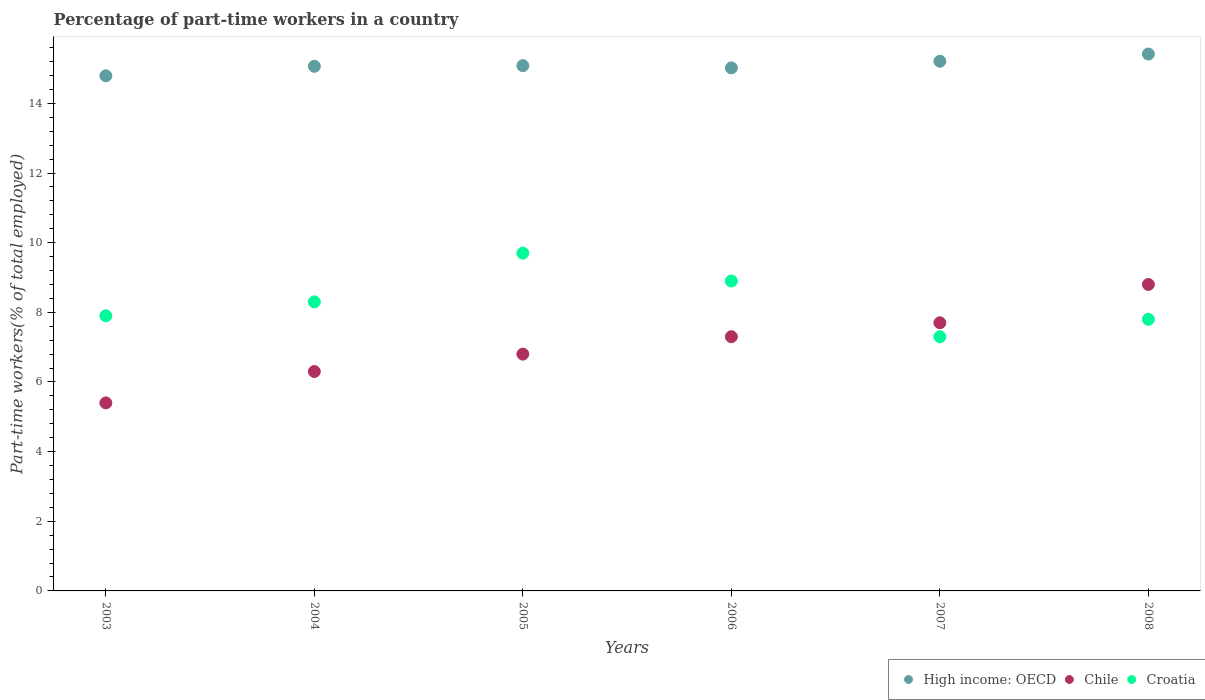How many different coloured dotlines are there?
Offer a very short reply. 3. Is the number of dotlines equal to the number of legend labels?
Offer a very short reply. Yes. What is the percentage of part-time workers in High income: OECD in 2003?
Offer a very short reply. 14.79. Across all years, what is the maximum percentage of part-time workers in High income: OECD?
Provide a succinct answer. 15.42. Across all years, what is the minimum percentage of part-time workers in Croatia?
Give a very brief answer. 7.3. In which year was the percentage of part-time workers in Chile maximum?
Offer a very short reply. 2008. In which year was the percentage of part-time workers in Croatia minimum?
Offer a terse response. 2007. What is the total percentage of part-time workers in Chile in the graph?
Offer a very short reply. 42.3. What is the difference between the percentage of part-time workers in Chile in 2005 and that in 2006?
Offer a terse response. -0.5. What is the difference between the percentage of part-time workers in Croatia in 2004 and the percentage of part-time workers in High income: OECD in 2007?
Keep it short and to the point. -6.91. What is the average percentage of part-time workers in Croatia per year?
Your answer should be very brief. 8.32. In the year 2005, what is the difference between the percentage of part-time workers in High income: OECD and percentage of part-time workers in Chile?
Ensure brevity in your answer.  8.28. What is the ratio of the percentage of part-time workers in Chile in 2003 to that in 2006?
Your answer should be compact. 0.74. What is the difference between the highest and the second highest percentage of part-time workers in High income: OECD?
Provide a short and direct response. 0.21. What is the difference between the highest and the lowest percentage of part-time workers in Croatia?
Provide a short and direct response. 2.4. Is it the case that in every year, the sum of the percentage of part-time workers in High income: OECD and percentage of part-time workers in Croatia  is greater than the percentage of part-time workers in Chile?
Make the answer very short. Yes. Does the percentage of part-time workers in Chile monotonically increase over the years?
Offer a very short reply. Yes. Is the percentage of part-time workers in Croatia strictly less than the percentage of part-time workers in Chile over the years?
Your answer should be very brief. No. How many years are there in the graph?
Offer a terse response. 6. What is the difference between two consecutive major ticks on the Y-axis?
Give a very brief answer. 2. Are the values on the major ticks of Y-axis written in scientific E-notation?
Offer a very short reply. No. Where does the legend appear in the graph?
Ensure brevity in your answer.  Bottom right. What is the title of the graph?
Your answer should be compact. Percentage of part-time workers in a country. Does "Albania" appear as one of the legend labels in the graph?
Your answer should be compact. No. What is the label or title of the X-axis?
Your answer should be very brief. Years. What is the label or title of the Y-axis?
Your response must be concise. Part-time workers(% of total employed). What is the Part-time workers(% of total employed) in High income: OECD in 2003?
Provide a succinct answer. 14.79. What is the Part-time workers(% of total employed) in Chile in 2003?
Your response must be concise. 5.4. What is the Part-time workers(% of total employed) in Croatia in 2003?
Offer a very short reply. 7.9. What is the Part-time workers(% of total employed) of High income: OECD in 2004?
Ensure brevity in your answer.  15.06. What is the Part-time workers(% of total employed) of Chile in 2004?
Provide a short and direct response. 6.3. What is the Part-time workers(% of total employed) in Croatia in 2004?
Offer a terse response. 8.3. What is the Part-time workers(% of total employed) in High income: OECD in 2005?
Keep it short and to the point. 15.08. What is the Part-time workers(% of total employed) in Chile in 2005?
Ensure brevity in your answer.  6.8. What is the Part-time workers(% of total employed) of Croatia in 2005?
Offer a very short reply. 9.7. What is the Part-time workers(% of total employed) in High income: OECD in 2006?
Give a very brief answer. 15.02. What is the Part-time workers(% of total employed) in Chile in 2006?
Your response must be concise. 7.3. What is the Part-time workers(% of total employed) of Croatia in 2006?
Your answer should be very brief. 8.9. What is the Part-time workers(% of total employed) in High income: OECD in 2007?
Make the answer very short. 15.21. What is the Part-time workers(% of total employed) of Chile in 2007?
Keep it short and to the point. 7.7. What is the Part-time workers(% of total employed) of Croatia in 2007?
Ensure brevity in your answer.  7.3. What is the Part-time workers(% of total employed) in High income: OECD in 2008?
Your answer should be compact. 15.42. What is the Part-time workers(% of total employed) of Chile in 2008?
Keep it short and to the point. 8.8. What is the Part-time workers(% of total employed) of Croatia in 2008?
Keep it short and to the point. 7.8. Across all years, what is the maximum Part-time workers(% of total employed) of High income: OECD?
Your answer should be very brief. 15.42. Across all years, what is the maximum Part-time workers(% of total employed) in Chile?
Offer a terse response. 8.8. Across all years, what is the maximum Part-time workers(% of total employed) of Croatia?
Provide a short and direct response. 9.7. Across all years, what is the minimum Part-time workers(% of total employed) of High income: OECD?
Ensure brevity in your answer.  14.79. Across all years, what is the minimum Part-time workers(% of total employed) of Chile?
Offer a terse response. 5.4. Across all years, what is the minimum Part-time workers(% of total employed) of Croatia?
Offer a very short reply. 7.3. What is the total Part-time workers(% of total employed) in High income: OECD in the graph?
Your answer should be compact. 90.59. What is the total Part-time workers(% of total employed) of Chile in the graph?
Your answer should be very brief. 42.3. What is the total Part-time workers(% of total employed) in Croatia in the graph?
Provide a short and direct response. 49.9. What is the difference between the Part-time workers(% of total employed) in High income: OECD in 2003 and that in 2004?
Make the answer very short. -0.27. What is the difference between the Part-time workers(% of total employed) in Chile in 2003 and that in 2004?
Give a very brief answer. -0.9. What is the difference between the Part-time workers(% of total employed) of Croatia in 2003 and that in 2004?
Ensure brevity in your answer.  -0.4. What is the difference between the Part-time workers(% of total employed) in High income: OECD in 2003 and that in 2005?
Ensure brevity in your answer.  -0.29. What is the difference between the Part-time workers(% of total employed) in Chile in 2003 and that in 2005?
Offer a very short reply. -1.4. What is the difference between the Part-time workers(% of total employed) of Croatia in 2003 and that in 2005?
Ensure brevity in your answer.  -1.8. What is the difference between the Part-time workers(% of total employed) in High income: OECD in 2003 and that in 2006?
Offer a terse response. -0.23. What is the difference between the Part-time workers(% of total employed) of High income: OECD in 2003 and that in 2007?
Offer a very short reply. -0.42. What is the difference between the Part-time workers(% of total employed) of Chile in 2003 and that in 2007?
Ensure brevity in your answer.  -2.3. What is the difference between the Part-time workers(% of total employed) of Croatia in 2003 and that in 2007?
Make the answer very short. 0.6. What is the difference between the Part-time workers(% of total employed) in High income: OECD in 2003 and that in 2008?
Offer a terse response. -0.63. What is the difference between the Part-time workers(% of total employed) of Chile in 2003 and that in 2008?
Ensure brevity in your answer.  -3.4. What is the difference between the Part-time workers(% of total employed) in Croatia in 2003 and that in 2008?
Your answer should be very brief. 0.1. What is the difference between the Part-time workers(% of total employed) in High income: OECD in 2004 and that in 2005?
Ensure brevity in your answer.  -0.02. What is the difference between the Part-time workers(% of total employed) in Croatia in 2004 and that in 2005?
Your answer should be very brief. -1.4. What is the difference between the Part-time workers(% of total employed) of High income: OECD in 2004 and that in 2006?
Your answer should be compact. 0.05. What is the difference between the Part-time workers(% of total employed) of Chile in 2004 and that in 2006?
Your answer should be very brief. -1. What is the difference between the Part-time workers(% of total employed) in High income: OECD in 2004 and that in 2007?
Keep it short and to the point. -0.14. What is the difference between the Part-time workers(% of total employed) in High income: OECD in 2004 and that in 2008?
Give a very brief answer. -0.35. What is the difference between the Part-time workers(% of total employed) in Chile in 2004 and that in 2008?
Your response must be concise. -2.5. What is the difference between the Part-time workers(% of total employed) in High income: OECD in 2005 and that in 2006?
Provide a succinct answer. 0.06. What is the difference between the Part-time workers(% of total employed) in Chile in 2005 and that in 2006?
Give a very brief answer. -0.5. What is the difference between the Part-time workers(% of total employed) of Croatia in 2005 and that in 2006?
Your response must be concise. 0.8. What is the difference between the Part-time workers(% of total employed) in High income: OECD in 2005 and that in 2007?
Your response must be concise. -0.12. What is the difference between the Part-time workers(% of total employed) of Chile in 2005 and that in 2007?
Your answer should be very brief. -0.9. What is the difference between the Part-time workers(% of total employed) of Croatia in 2005 and that in 2007?
Keep it short and to the point. 2.4. What is the difference between the Part-time workers(% of total employed) of High income: OECD in 2005 and that in 2008?
Your answer should be very brief. -0.33. What is the difference between the Part-time workers(% of total employed) of Croatia in 2005 and that in 2008?
Provide a succinct answer. 1.9. What is the difference between the Part-time workers(% of total employed) in High income: OECD in 2006 and that in 2007?
Your response must be concise. -0.19. What is the difference between the Part-time workers(% of total employed) in Chile in 2006 and that in 2007?
Your answer should be compact. -0.4. What is the difference between the Part-time workers(% of total employed) of Croatia in 2006 and that in 2007?
Give a very brief answer. 1.6. What is the difference between the Part-time workers(% of total employed) of High income: OECD in 2006 and that in 2008?
Ensure brevity in your answer.  -0.4. What is the difference between the Part-time workers(% of total employed) of Croatia in 2006 and that in 2008?
Give a very brief answer. 1.1. What is the difference between the Part-time workers(% of total employed) of High income: OECD in 2007 and that in 2008?
Offer a very short reply. -0.21. What is the difference between the Part-time workers(% of total employed) in Chile in 2007 and that in 2008?
Offer a very short reply. -1.1. What is the difference between the Part-time workers(% of total employed) in High income: OECD in 2003 and the Part-time workers(% of total employed) in Chile in 2004?
Provide a short and direct response. 8.49. What is the difference between the Part-time workers(% of total employed) in High income: OECD in 2003 and the Part-time workers(% of total employed) in Croatia in 2004?
Your response must be concise. 6.49. What is the difference between the Part-time workers(% of total employed) in High income: OECD in 2003 and the Part-time workers(% of total employed) in Chile in 2005?
Provide a succinct answer. 7.99. What is the difference between the Part-time workers(% of total employed) of High income: OECD in 2003 and the Part-time workers(% of total employed) of Croatia in 2005?
Your answer should be very brief. 5.09. What is the difference between the Part-time workers(% of total employed) in Chile in 2003 and the Part-time workers(% of total employed) in Croatia in 2005?
Keep it short and to the point. -4.3. What is the difference between the Part-time workers(% of total employed) in High income: OECD in 2003 and the Part-time workers(% of total employed) in Chile in 2006?
Your answer should be compact. 7.49. What is the difference between the Part-time workers(% of total employed) of High income: OECD in 2003 and the Part-time workers(% of total employed) of Croatia in 2006?
Provide a short and direct response. 5.89. What is the difference between the Part-time workers(% of total employed) of High income: OECD in 2003 and the Part-time workers(% of total employed) of Chile in 2007?
Provide a short and direct response. 7.09. What is the difference between the Part-time workers(% of total employed) in High income: OECD in 2003 and the Part-time workers(% of total employed) in Croatia in 2007?
Your response must be concise. 7.49. What is the difference between the Part-time workers(% of total employed) in Chile in 2003 and the Part-time workers(% of total employed) in Croatia in 2007?
Keep it short and to the point. -1.9. What is the difference between the Part-time workers(% of total employed) in High income: OECD in 2003 and the Part-time workers(% of total employed) in Chile in 2008?
Offer a terse response. 5.99. What is the difference between the Part-time workers(% of total employed) of High income: OECD in 2003 and the Part-time workers(% of total employed) of Croatia in 2008?
Offer a terse response. 6.99. What is the difference between the Part-time workers(% of total employed) of Chile in 2003 and the Part-time workers(% of total employed) of Croatia in 2008?
Provide a short and direct response. -2.4. What is the difference between the Part-time workers(% of total employed) in High income: OECD in 2004 and the Part-time workers(% of total employed) in Chile in 2005?
Offer a very short reply. 8.26. What is the difference between the Part-time workers(% of total employed) in High income: OECD in 2004 and the Part-time workers(% of total employed) in Croatia in 2005?
Your response must be concise. 5.36. What is the difference between the Part-time workers(% of total employed) in Chile in 2004 and the Part-time workers(% of total employed) in Croatia in 2005?
Ensure brevity in your answer.  -3.4. What is the difference between the Part-time workers(% of total employed) in High income: OECD in 2004 and the Part-time workers(% of total employed) in Chile in 2006?
Provide a short and direct response. 7.76. What is the difference between the Part-time workers(% of total employed) in High income: OECD in 2004 and the Part-time workers(% of total employed) in Croatia in 2006?
Provide a short and direct response. 6.16. What is the difference between the Part-time workers(% of total employed) in High income: OECD in 2004 and the Part-time workers(% of total employed) in Chile in 2007?
Your answer should be compact. 7.36. What is the difference between the Part-time workers(% of total employed) of High income: OECD in 2004 and the Part-time workers(% of total employed) of Croatia in 2007?
Offer a very short reply. 7.76. What is the difference between the Part-time workers(% of total employed) in High income: OECD in 2004 and the Part-time workers(% of total employed) in Chile in 2008?
Ensure brevity in your answer.  6.26. What is the difference between the Part-time workers(% of total employed) of High income: OECD in 2004 and the Part-time workers(% of total employed) of Croatia in 2008?
Make the answer very short. 7.26. What is the difference between the Part-time workers(% of total employed) in High income: OECD in 2005 and the Part-time workers(% of total employed) in Chile in 2006?
Make the answer very short. 7.78. What is the difference between the Part-time workers(% of total employed) of High income: OECD in 2005 and the Part-time workers(% of total employed) of Croatia in 2006?
Offer a terse response. 6.18. What is the difference between the Part-time workers(% of total employed) in Chile in 2005 and the Part-time workers(% of total employed) in Croatia in 2006?
Your answer should be compact. -2.1. What is the difference between the Part-time workers(% of total employed) in High income: OECD in 2005 and the Part-time workers(% of total employed) in Chile in 2007?
Provide a succinct answer. 7.38. What is the difference between the Part-time workers(% of total employed) of High income: OECD in 2005 and the Part-time workers(% of total employed) of Croatia in 2007?
Your answer should be very brief. 7.78. What is the difference between the Part-time workers(% of total employed) of Chile in 2005 and the Part-time workers(% of total employed) of Croatia in 2007?
Your answer should be compact. -0.5. What is the difference between the Part-time workers(% of total employed) of High income: OECD in 2005 and the Part-time workers(% of total employed) of Chile in 2008?
Your response must be concise. 6.28. What is the difference between the Part-time workers(% of total employed) of High income: OECD in 2005 and the Part-time workers(% of total employed) of Croatia in 2008?
Keep it short and to the point. 7.28. What is the difference between the Part-time workers(% of total employed) in High income: OECD in 2006 and the Part-time workers(% of total employed) in Chile in 2007?
Offer a very short reply. 7.32. What is the difference between the Part-time workers(% of total employed) in High income: OECD in 2006 and the Part-time workers(% of total employed) in Croatia in 2007?
Provide a short and direct response. 7.72. What is the difference between the Part-time workers(% of total employed) of High income: OECD in 2006 and the Part-time workers(% of total employed) of Chile in 2008?
Your answer should be very brief. 6.22. What is the difference between the Part-time workers(% of total employed) of High income: OECD in 2006 and the Part-time workers(% of total employed) of Croatia in 2008?
Ensure brevity in your answer.  7.22. What is the difference between the Part-time workers(% of total employed) of Chile in 2006 and the Part-time workers(% of total employed) of Croatia in 2008?
Your answer should be compact. -0.5. What is the difference between the Part-time workers(% of total employed) in High income: OECD in 2007 and the Part-time workers(% of total employed) in Chile in 2008?
Your answer should be compact. 6.41. What is the difference between the Part-time workers(% of total employed) of High income: OECD in 2007 and the Part-time workers(% of total employed) of Croatia in 2008?
Your answer should be very brief. 7.41. What is the average Part-time workers(% of total employed) in High income: OECD per year?
Ensure brevity in your answer.  15.1. What is the average Part-time workers(% of total employed) of Chile per year?
Offer a very short reply. 7.05. What is the average Part-time workers(% of total employed) in Croatia per year?
Provide a short and direct response. 8.32. In the year 2003, what is the difference between the Part-time workers(% of total employed) in High income: OECD and Part-time workers(% of total employed) in Chile?
Ensure brevity in your answer.  9.39. In the year 2003, what is the difference between the Part-time workers(% of total employed) of High income: OECD and Part-time workers(% of total employed) of Croatia?
Keep it short and to the point. 6.89. In the year 2004, what is the difference between the Part-time workers(% of total employed) of High income: OECD and Part-time workers(% of total employed) of Chile?
Offer a terse response. 8.76. In the year 2004, what is the difference between the Part-time workers(% of total employed) of High income: OECD and Part-time workers(% of total employed) of Croatia?
Keep it short and to the point. 6.76. In the year 2005, what is the difference between the Part-time workers(% of total employed) in High income: OECD and Part-time workers(% of total employed) in Chile?
Give a very brief answer. 8.28. In the year 2005, what is the difference between the Part-time workers(% of total employed) of High income: OECD and Part-time workers(% of total employed) of Croatia?
Your answer should be compact. 5.38. In the year 2005, what is the difference between the Part-time workers(% of total employed) of Chile and Part-time workers(% of total employed) of Croatia?
Make the answer very short. -2.9. In the year 2006, what is the difference between the Part-time workers(% of total employed) in High income: OECD and Part-time workers(% of total employed) in Chile?
Keep it short and to the point. 7.72. In the year 2006, what is the difference between the Part-time workers(% of total employed) of High income: OECD and Part-time workers(% of total employed) of Croatia?
Your answer should be compact. 6.12. In the year 2006, what is the difference between the Part-time workers(% of total employed) of Chile and Part-time workers(% of total employed) of Croatia?
Provide a succinct answer. -1.6. In the year 2007, what is the difference between the Part-time workers(% of total employed) of High income: OECD and Part-time workers(% of total employed) of Chile?
Your answer should be compact. 7.51. In the year 2007, what is the difference between the Part-time workers(% of total employed) in High income: OECD and Part-time workers(% of total employed) in Croatia?
Keep it short and to the point. 7.91. In the year 2008, what is the difference between the Part-time workers(% of total employed) of High income: OECD and Part-time workers(% of total employed) of Chile?
Ensure brevity in your answer.  6.62. In the year 2008, what is the difference between the Part-time workers(% of total employed) of High income: OECD and Part-time workers(% of total employed) of Croatia?
Ensure brevity in your answer.  7.62. What is the ratio of the Part-time workers(% of total employed) in High income: OECD in 2003 to that in 2004?
Give a very brief answer. 0.98. What is the ratio of the Part-time workers(% of total employed) of Croatia in 2003 to that in 2004?
Keep it short and to the point. 0.95. What is the ratio of the Part-time workers(% of total employed) of High income: OECD in 2003 to that in 2005?
Your response must be concise. 0.98. What is the ratio of the Part-time workers(% of total employed) of Chile in 2003 to that in 2005?
Keep it short and to the point. 0.79. What is the ratio of the Part-time workers(% of total employed) in Croatia in 2003 to that in 2005?
Make the answer very short. 0.81. What is the ratio of the Part-time workers(% of total employed) in High income: OECD in 2003 to that in 2006?
Give a very brief answer. 0.98. What is the ratio of the Part-time workers(% of total employed) of Chile in 2003 to that in 2006?
Provide a short and direct response. 0.74. What is the ratio of the Part-time workers(% of total employed) in Croatia in 2003 to that in 2006?
Offer a terse response. 0.89. What is the ratio of the Part-time workers(% of total employed) of High income: OECD in 2003 to that in 2007?
Your answer should be very brief. 0.97. What is the ratio of the Part-time workers(% of total employed) in Chile in 2003 to that in 2007?
Offer a very short reply. 0.7. What is the ratio of the Part-time workers(% of total employed) in Croatia in 2003 to that in 2007?
Your answer should be very brief. 1.08. What is the ratio of the Part-time workers(% of total employed) of High income: OECD in 2003 to that in 2008?
Your answer should be compact. 0.96. What is the ratio of the Part-time workers(% of total employed) of Chile in 2003 to that in 2008?
Your answer should be very brief. 0.61. What is the ratio of the Part-time workers(% of total employed) of Croatia in 2003 to that in 2008?
Your response must be concise. 1.01. What is the ratio of the Part-time workers(% of total employed) of High income: OECD in 2004 to that in 2005?
Keep it short and to the point. 1. What is the ratio of the Part-time workers(% of total employed) in Chile in 2004 to that in 2005?
Provide a short and direct response. 0.93. What is the ratio of the Part-time workers(% of total employed) in Croatia in 2004 to that in 2005?
Your response must be concise. 0.86. What is the ratio of the Part-time workers(% of total employed) in Chile in 2004 to that in 2006?
Offer a terse response. 0.86. What is the ratio of the Part-time workers(% of total employed) in Croatia in 2004 to that in 2006?
Your answer should be very brief. 0.93. What is the ratio of the Part-time workers(% of total employed) in Chile in 2004 to that in 2007?
Your answer should be very brief. 0.82. What is the ratio of the Part-time workers(% of total employed) of Croatia in 2004 to that in 2007?
Give a very brief answer. 1.14. What is the ratio of the Part-time workers(% of total employed) in High income: OECD in 2004 to that in 2008?
Your answer should be very brief. 0.98. What is the ratio of the Part-time workers(% of total employed) of Chile in 2004 to that in 2008?
Your answer should be compact. 0.72. What is the ratio of the Part-time workers(% of total employed) in Croatia in 2004 to that in 2008?
Your answer should be compact. 1.06. What is the ratio of the Part-time workers(% of total employed) of Chile in 2005 to that in 2006?
Your answer should be very brief. 0.93. What is the ratio of the Part-time workers(% of total employed) of Croatia in 2005 to that in 2006?
Provide a short and direct response. 1.09. What is the ratio of the Part-time workers(% of total employed) of Chile in 2005 to that in 2007?
Provide a succinct answer. 0.88. What is the ratio of the Part-time workers(% of total employed) in Croatia in 2005 to that in 2007?
Your answer should be compact. 1.33. What is the ratio of the Part-time workers(% of total employed) in High income: OECD in 2005 to that in 2008?
Offer a very short reply. 0.98. What is the ratio of the Part-time workers(% of total employed) of Chile in 2005 to that in 2008?
Ensure brevity in your answer.  0.77. What is the ratio of the Part-time workers(% of total employed) in Croatia in 2005 to that in 2008?
Offer a terse response. 1.24. What is the ratio of the Part-time workers(% of total employed) in High income: OECD in 2006 to that in 2007?
Keep it short and to the point. 0.99. What is the ratio of the Part-time workers(% of total employed) in Chile in 2006 to that in 2007?
Your answer should be compact. 0.95. What is the ratio of the Part-time workers(% of total employed) of Croatia in 2006 to that in 2007?
Give a very brief answer. 1.22. What is the ratio of the Part-time workers(% of total employed) in High income: OECD in 2006 to that in 2008?
Ensure brevity in your answer.  0.97. What is the ratio of the Part-time workers(% of total employed) in Chile in 2006 to that in 2008?
Offer a very short reply. 0.83. What is the ratio of the Part-time workers(% of total employed) in Croatia in 2006 to that in 2008?
Your answer should be compact. 1.14. What is the ratio of the Part-time workers(% of total employed) in High income: OECD in 2007 to that in 2008?
Your answer should be very brief. 0.99. What is the ratio of the Part-time workers(% of total employed) in Chile in 2007 to that in 2008?
Provide a short and direct response. 0.88. What is the ratio of the Part-time workers(% of total employed) in Croatia in 2007 to that in 2008?
Keep it short and to the point. 0.94. What is the difference between the highest and the second highest Part-time workers(% of total employed) of High income: OECD?
Make the answer very short. 0.21. What is the difference between the highest and the second highest Part-time workers(% of total employed) of Chile?
Provide a short and direct response. 1.1. What is the difference between the highest and the lowest Part-time workers(% of total employed) of High income: OECD?
Keep it short and to the point. 0.63. 